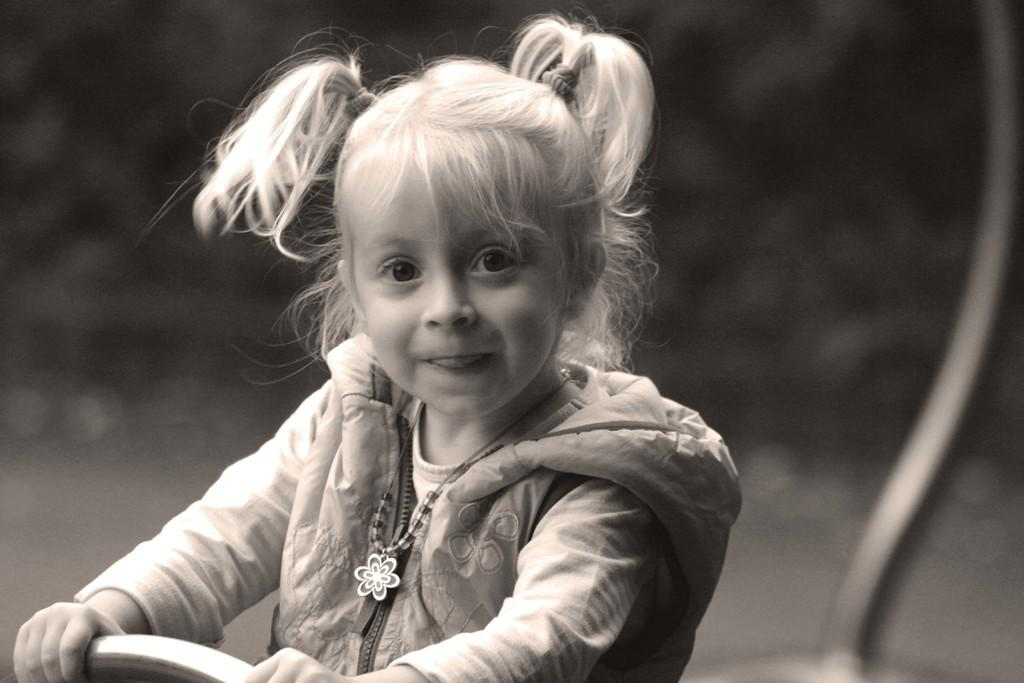What is the color scheme of the image? The image is black and white. What is the kid doing in the image? The kid is holding an object in the image. Can you describe the background of the image? The background of the image is blurred. What can be seen on the right side of the image? There is an object on the right side of the image. How many balloons are floating in the air in the image? There are no balloons present in the image. What type of jar is the kid holding in the image? The kid is not holding a jar in the image; they are holding an unspecified object. 